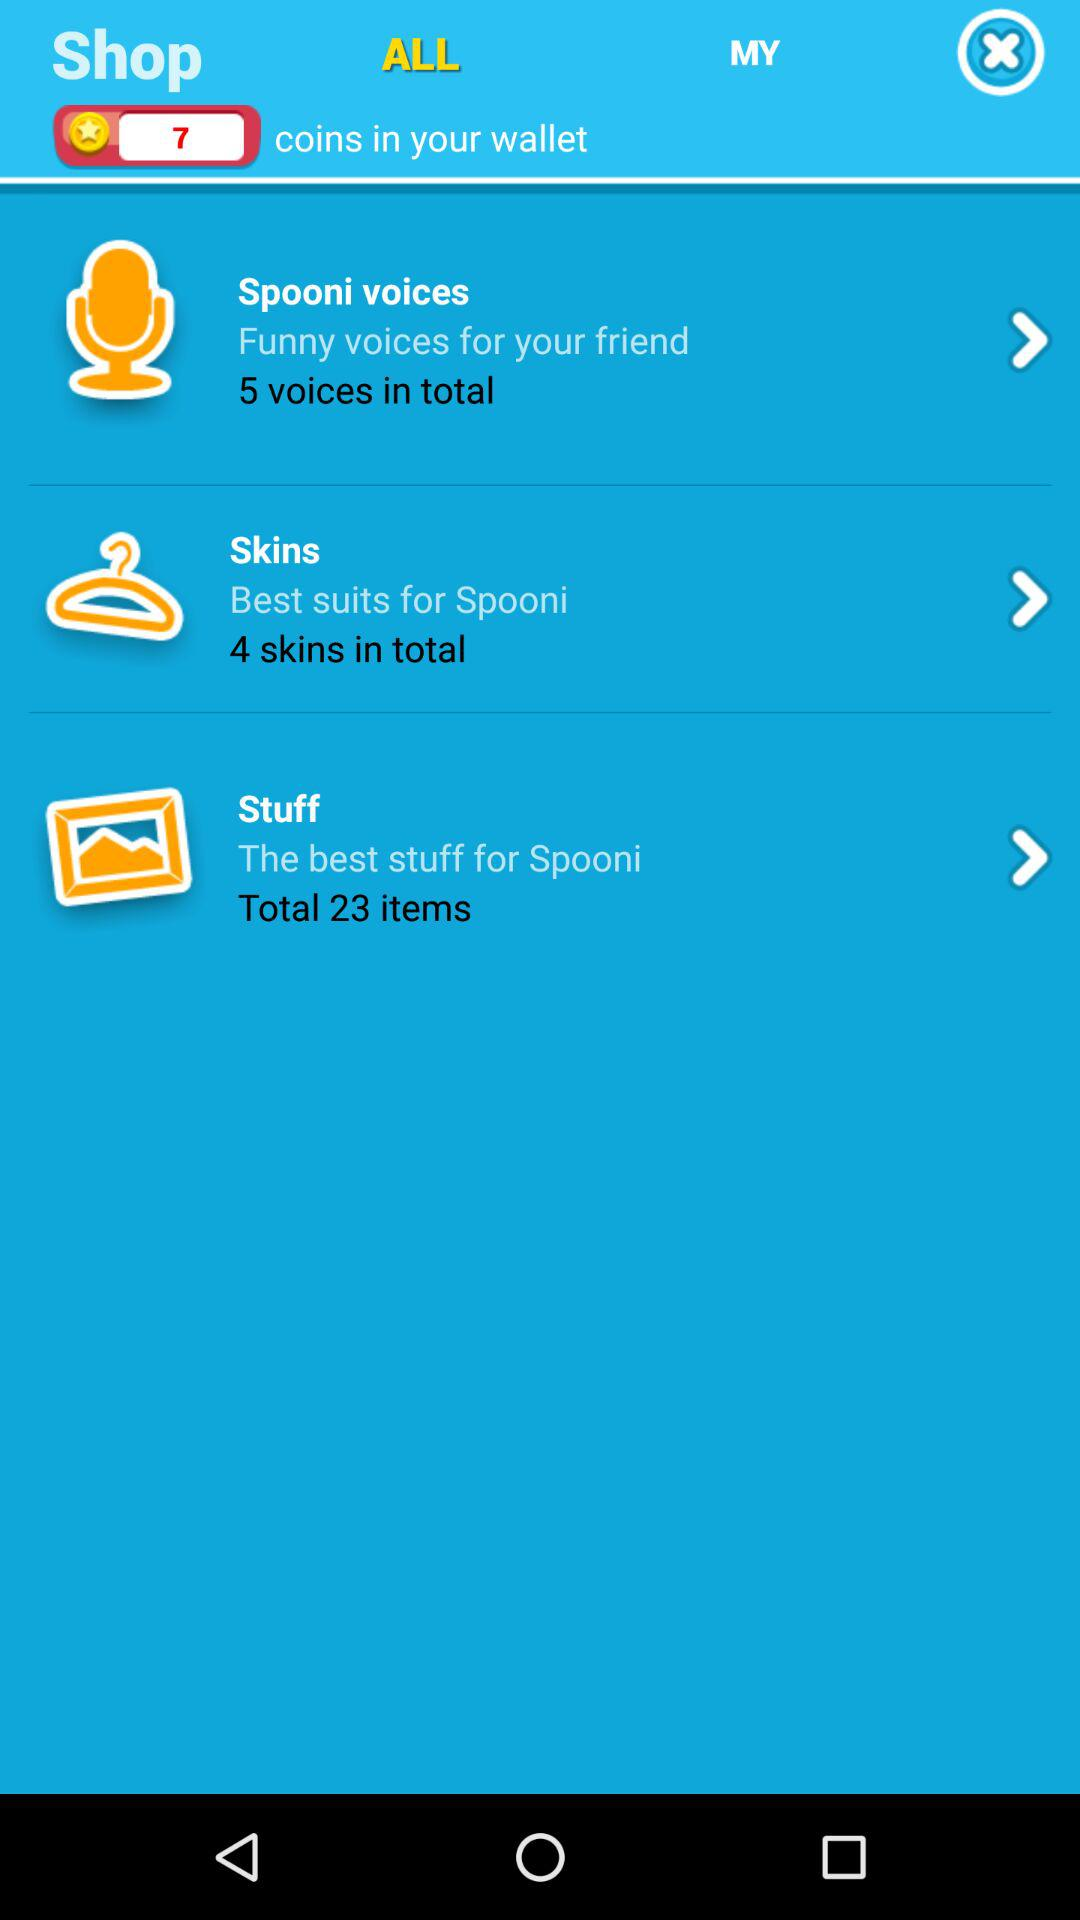Which option is selected? The selected option is "ALL". 